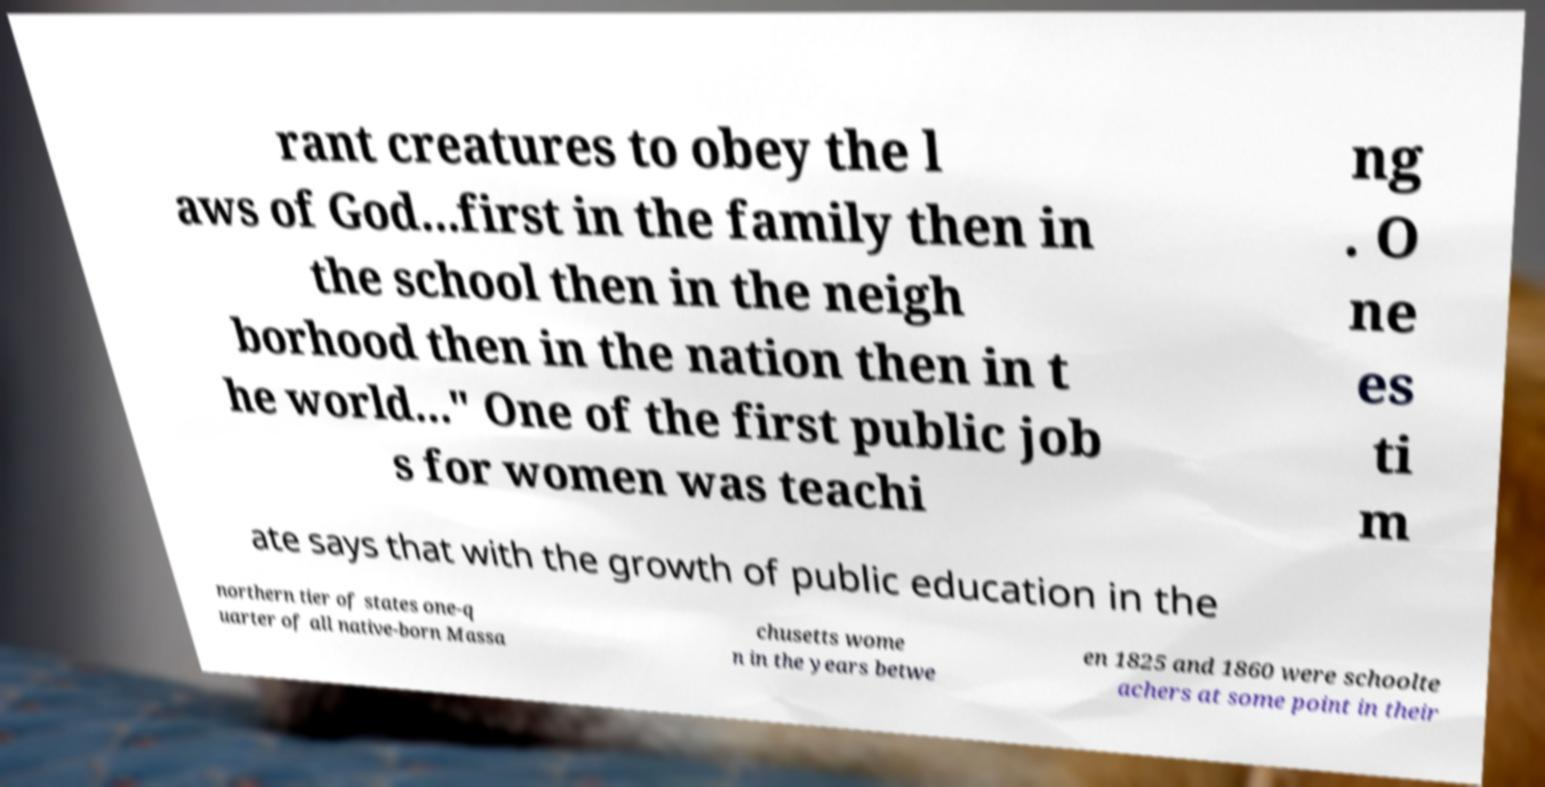Could you extract and type out the text from this image? rant creatures to obey the l aws of God...first in the family then in the school then in the neigh borhood then in the nation then in t he world..." One of the first public job s for women was teachi ng . O ne es ti m ate says that with the growth of public education in the northern tier of states one-q uarter of all native-born Massa chusetts wome n in the years betwe en 1825 and 1860 were schoolte achers at some point in their 